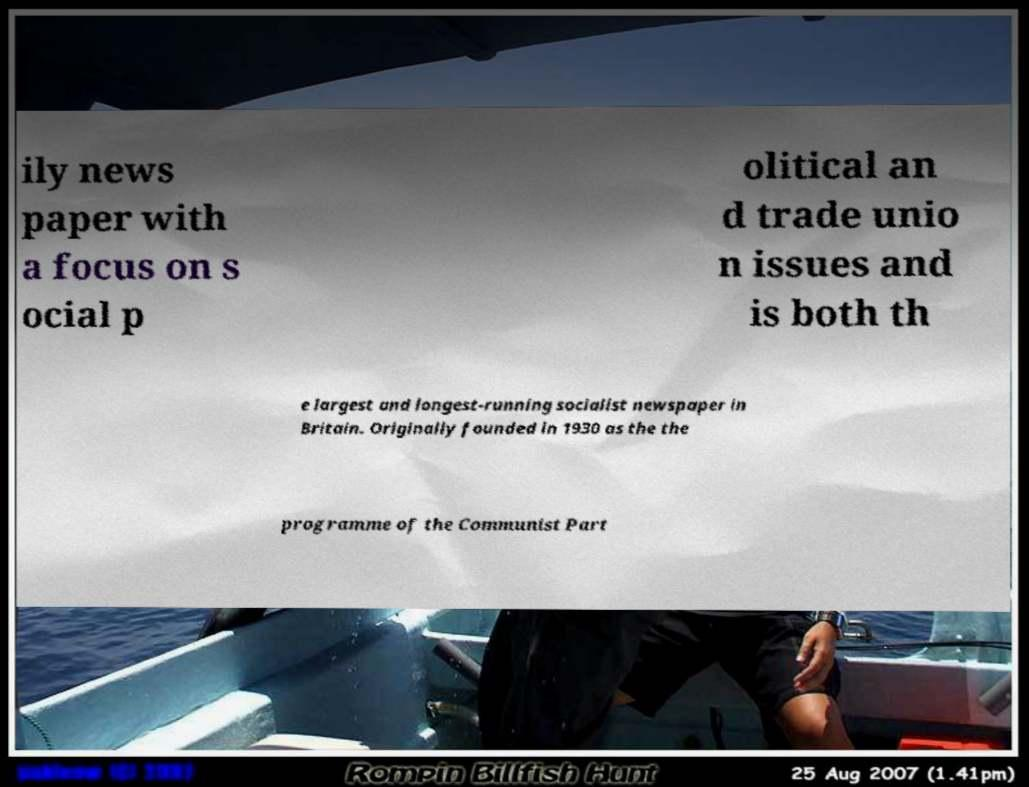For documentation purposes, I need the text within this image transcribed. Could you provide that? ily news paper with a focus on s ocial p olitical an d trade unio n issues and is both th e largest and longest-running socialist newspaper in Britain. Originally founded in 1930 as the the programme of the Communist Part 